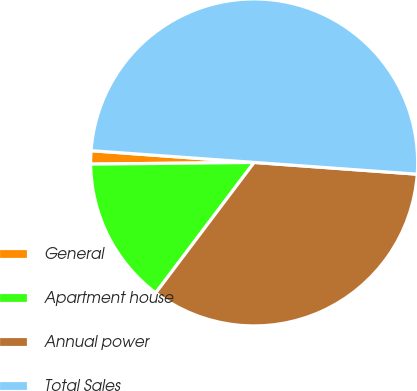<chart> <loc_0><loc_0><loc_500><loc_500><pie_chart><fcel>General<fcel>Apartment house<fcel>Annual power<fcel>Total Sales<nl><fcel>1.31%<fcel>14.55%<fcel>34.14%<fcel>50.0%<nl></chart> 